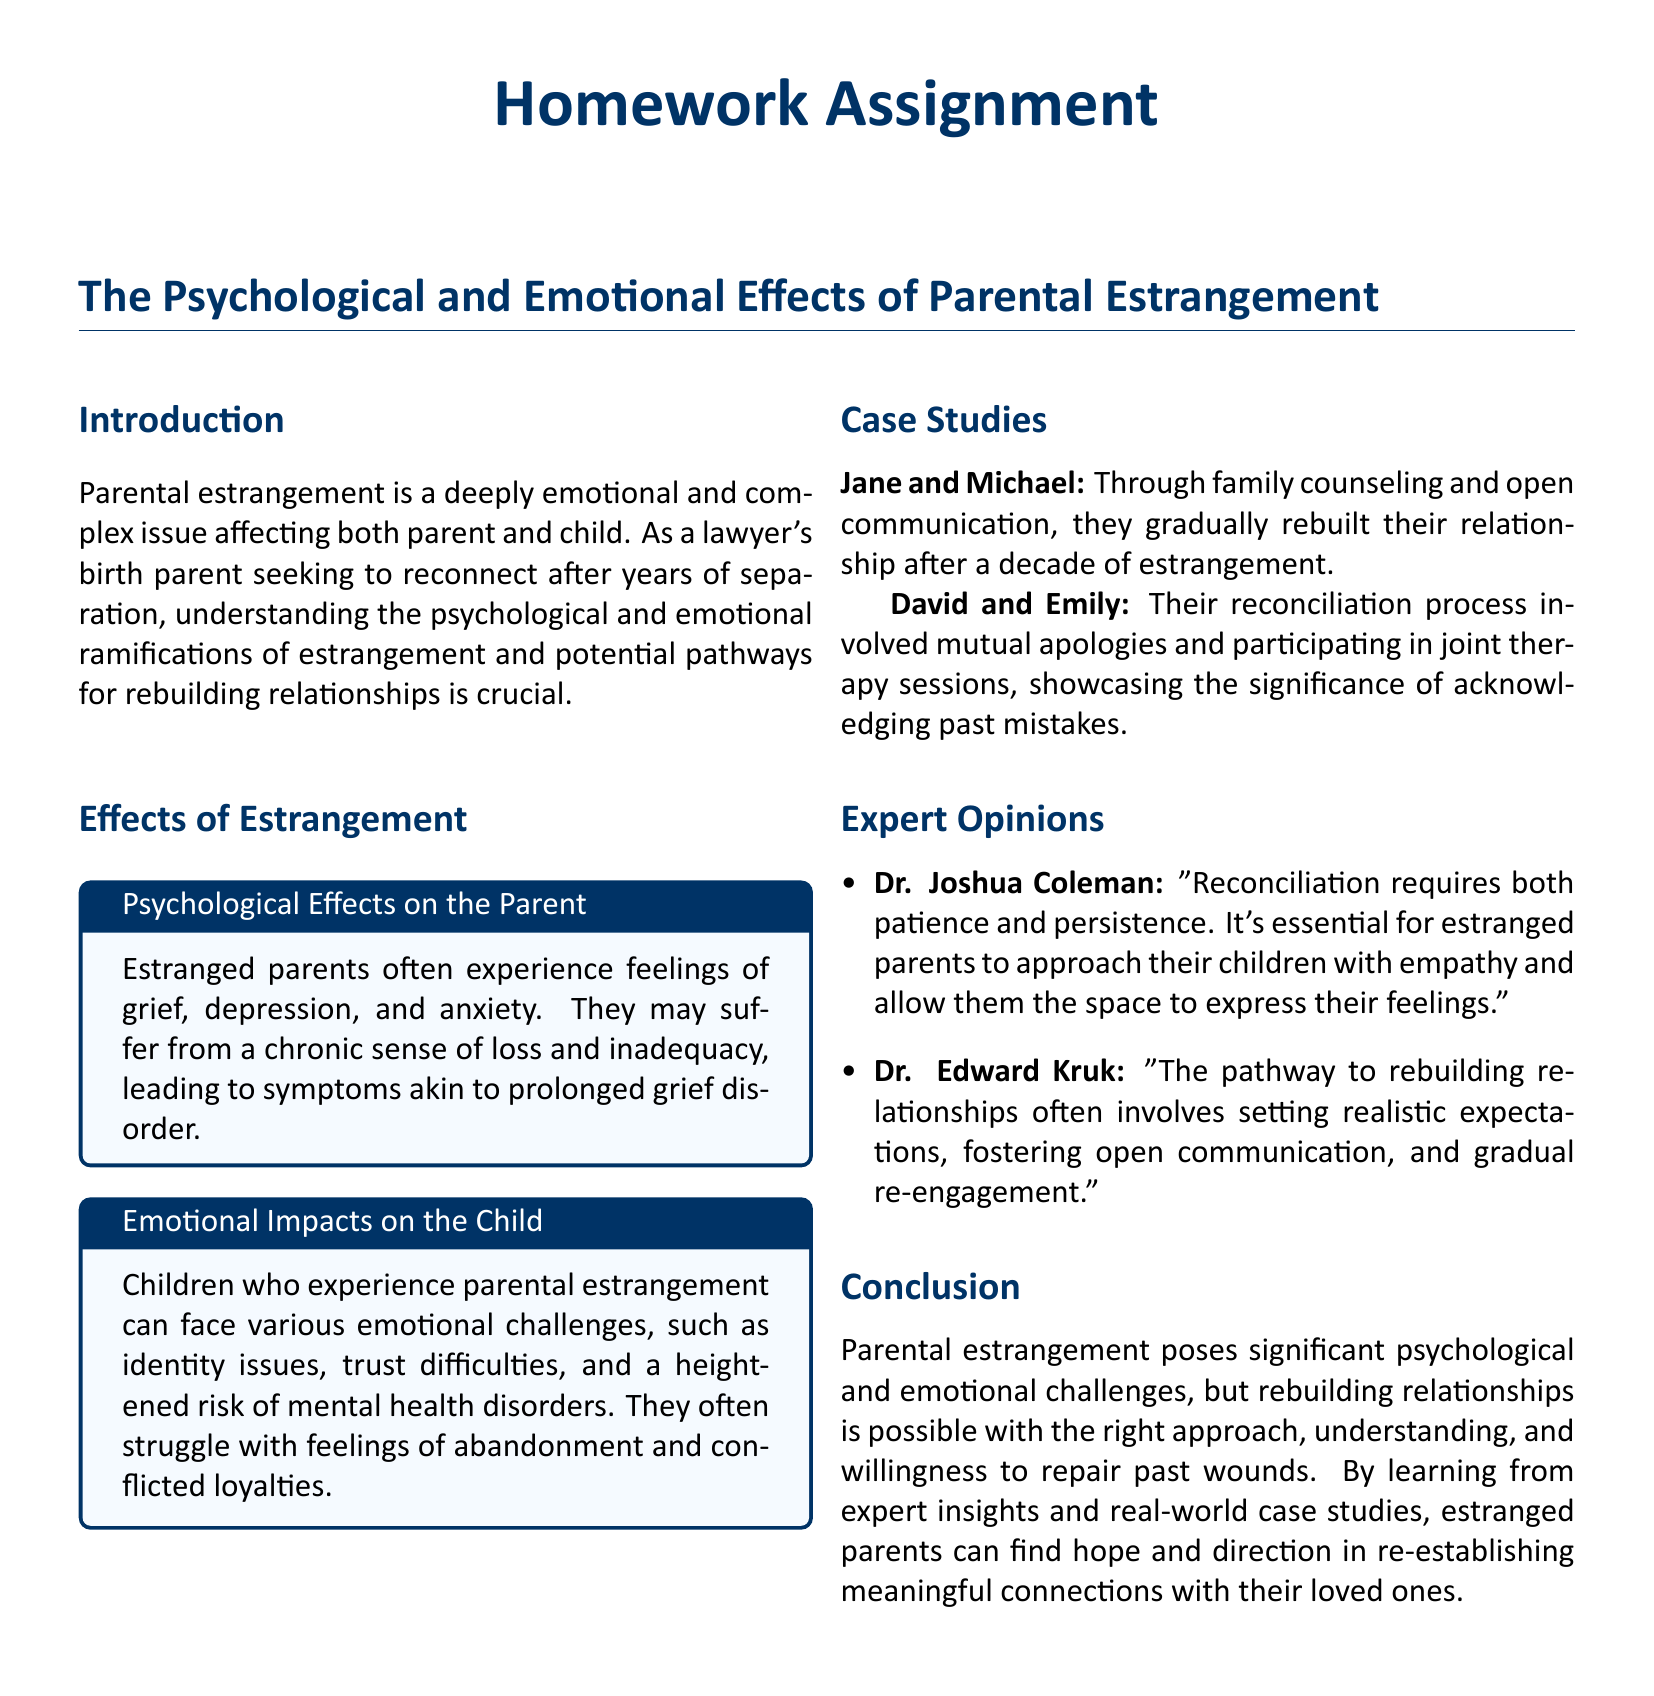What are the psychological effects on the parent? The document lists psychological effects such as grief, depression, and anxiety experienced by estranged parents.
Answer: Grief, depression, anxiety What emotional challenges do children face? The document states that children facing parental estrangement can experience identity issues and trust difficulties, among others.
Answer: Identity issues, trust difficulties What case study is mentioned involving family counseling? The document provides a case study of Jane and Michael, who rebuilt their relationship through family counseling.
Answer: Jane and Michael Who is Dr. Joshua Coleman? The document identifies Dr. Joshua Coleman as an expert who discusses reconciliation and empathy in estrangement.
Answer: Expert What is a key factor in the reconciliation process according to David and Emily's case study? The document emphasizes that mutual apologies and joint therapy sessions were significant in David and Emily's reconciliation.
Answer: Mutual apologies, joint therapy sessions What does Dr. Edward Kruk suggest for rebuilding relationships? The document cites Dr. Edward Kruk recommending realistic expectations and open communication as important for rebuilding relationships.
Answer: Realistic expectations, open communication What can estranged parents find from expert insights? The conclusion states that estranged parents can find hope and direction from expert insights.
Answer: Hope and direction What is the primary focus of this homework assignment? The title indicates that the assignment focuses on the psychological and emotional effects of parental estrangement.
Answer: Psychological and emotional effects 